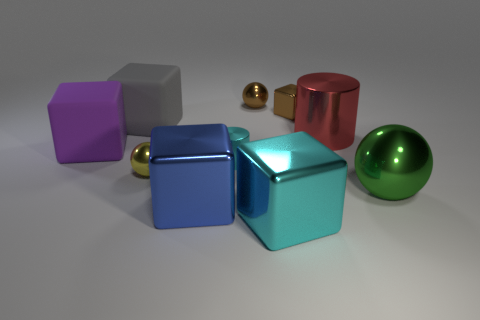Can you describe the colors of the objects shown in the image? Certainly! The image displays a selection of objects in various colors. There's a purple cube, a gray cube, a red cylinder, two small golden spheres, and two larger spheres – one is green and the other is teal. Each object's color has a metallic sheen that adds to the visual interest of the scene. 